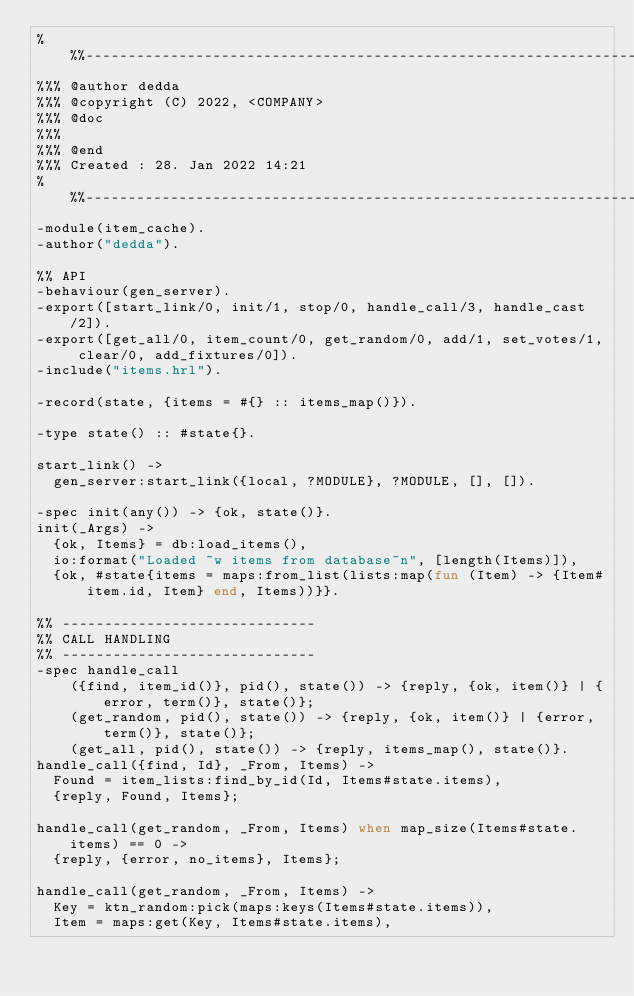Convert code to text. <code><loc_0><loc_0><loc_500><loc_500><_Erlang_>%%%-------------------------------------------------------------------
%%% @author dedda
%%% @copyright (C) 2022, <COMPANY>
%%% @doc
%%%
%%% @end
%%% Created : 28. Jan 2022 14:21
%%%-------------------------------------------------------------------
-module(item_cache).
-author("dedda").

%% API
-behaviour(gen_server).
-export([start_link/0, init/1, stop/0, handle_call/3, handle_cast/2]).
-export([get_all/0, item_count/0, get_random/0, add/1, set_votes/1, clear/0, add_fixtures/0]).
-include("items.hrl").

-record(state, {items = #{} :: items_map()}).

-type state() :: #state{}.

start_link() ->
  gen_server:start_link({local, ?MODULE}, ?MODULE, [], []).

-spec init(any()) -> {ok, state()}.
init(_Args) ->
  {ok, Items} = db:load_items(),
  io:format("Loaded ~w items from database~n", [length(Items)]),
  {ok, #state{items = maps:from_list(lists:map(fun (Item) -> {Item#item.id, Item} end, Items))}}.

%% ------------------------------
%% CALL HANDLING
%% ------------------------------
-spec handle_call
    ({find, item_id()}, pid(), state()) -> {reply, {ok, item()} | {error, term()}, state()};
    (get_random, pid(), state()) -> {reply, {ok, item()} | {error, term()}, state()};
    (get_all, pid(), state()) -> {reply, items_map(), state()}.
handle_call({find, Id}, _From, Items) ->
  Found = item_lists:find_by_id(Id, Items#state.items),
  {reply, Found, Items};

handle_call(get_random, _From, Items) when map_size(Items#state.items) == 0 ->
  {reply, {error, no_items}, Items};

handle_call(get_random, _From, Items) ->
  Key = ktn_random:pick(maps:keys(Items#state.items)),
  Item = maps:get(Key, Items#state.items),</code> 